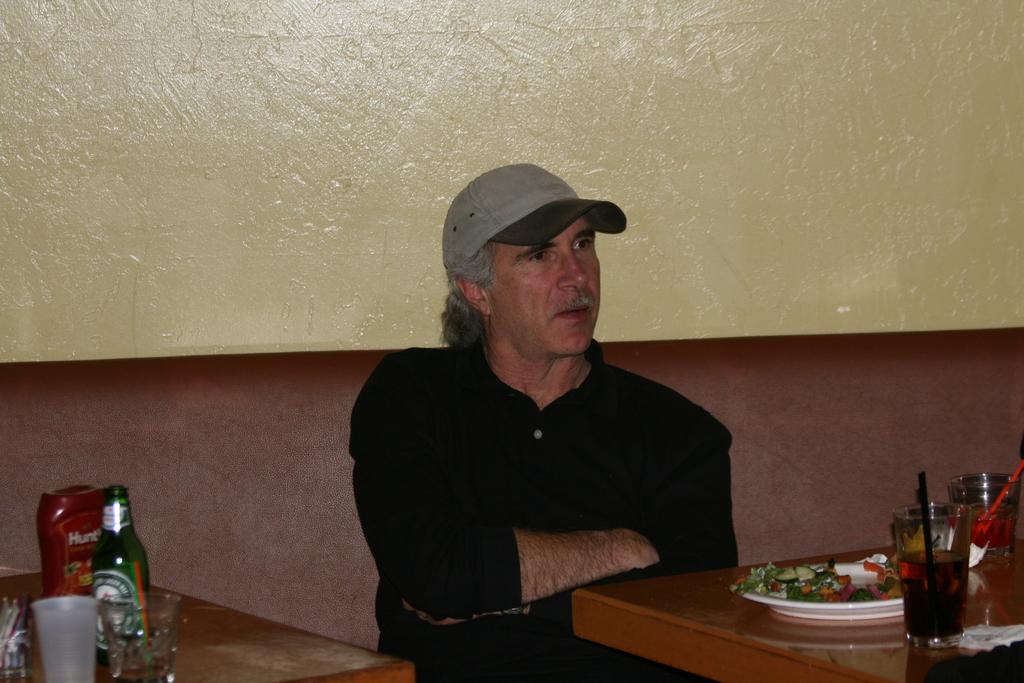What kind of beer is on the table?
Provide a succinct answer. Answering does not require reading text in the image. What kind of ketchup is on the table?
Give a very brief answer. Hunts. 